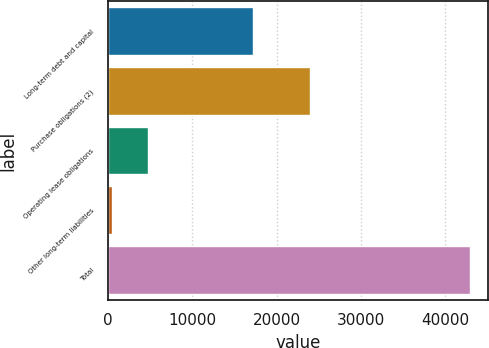Convert chart. <chart><loc_0><loc_0><loc_500><loc_500><bar_chart><fcel>Long-term debt and capital<fcel>Purchase obligations (2)<fcel>Operating lease obligations<fcel>Other long-term liabilities<fcel>Total<nl><fcel>17194<fcel>23918<fcel>4712.7<fcel>464<fcel>42951<nl></chart> 